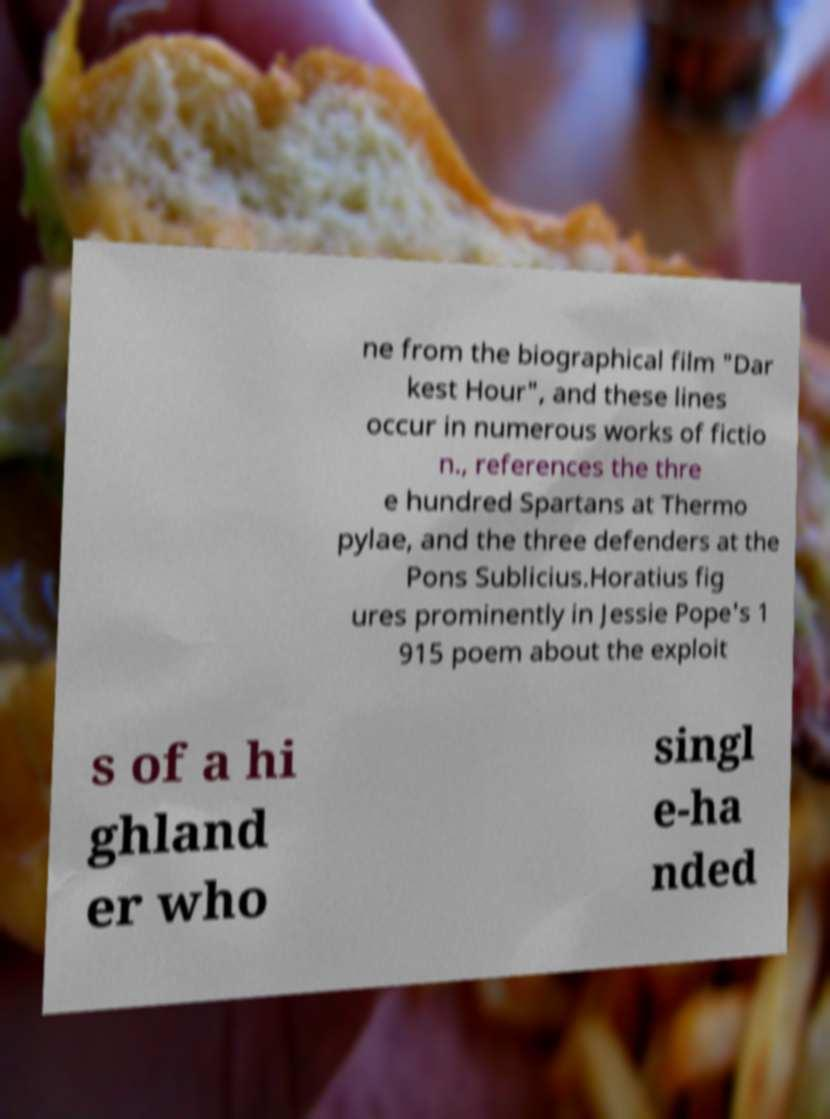There's text embedded in this image that I need extracted. Can you transcribe it verbatim? ne from the biographical film "Dar kest Hour", and these lines occur in numerous works of fictio n., references the thre e hundred Spartans at Thermo pylae, and the three defenders at the Pons Sublicius.Horatius fig ures prominently in Jessie Pope's 1 915 poem about the exploit s of a hi ghland er who singl e-ha nded 